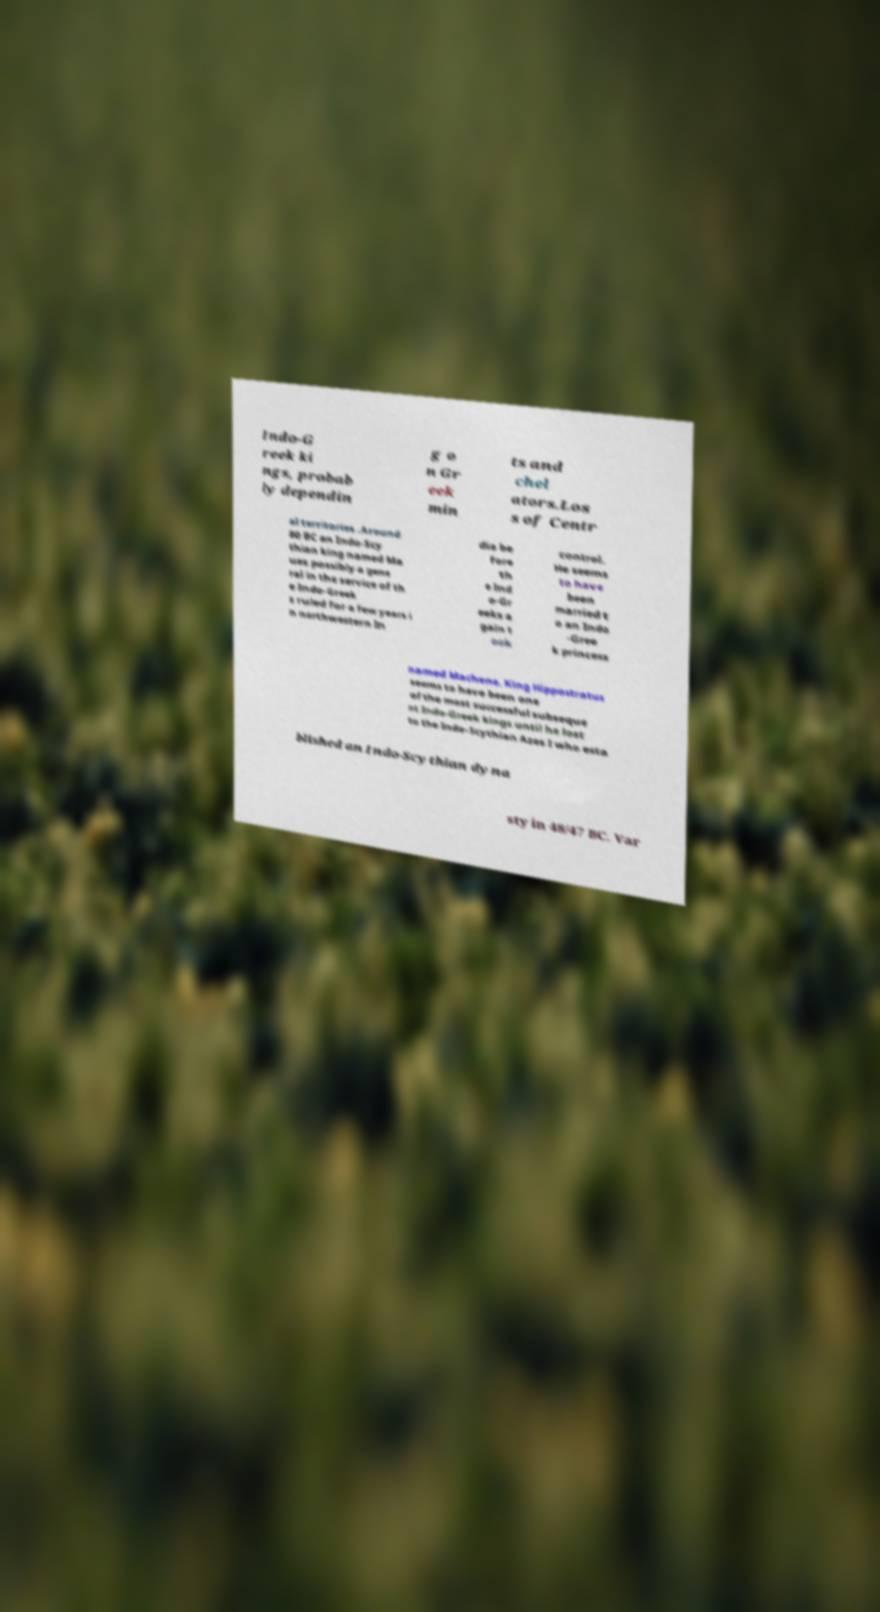For documentation purposes, I need the text within this image transcribed. Could you provide that? Indo-G reek ki ngs, probab ly dependin g o n Gr eek min ts and chel ators.Los s of Centr al territories .Around 80 BC an Indo-Scy thian king named Ma ues possibly a gene ral in the service of th e Indo-Greek s ruled for a few years i n northwestern In dia be fore th e Ind o-Gr eeks a gain t ook control. He seems to have been married t o an Indo -Gree k princess named Machene. King Hippostratus seems to have been one of the most successful subseque nt Indo-Greek kings until he lost to the Indo-Scythian Azes I who esta blished an Indo-Scythian dyna sty in 48/47 BC. Var 